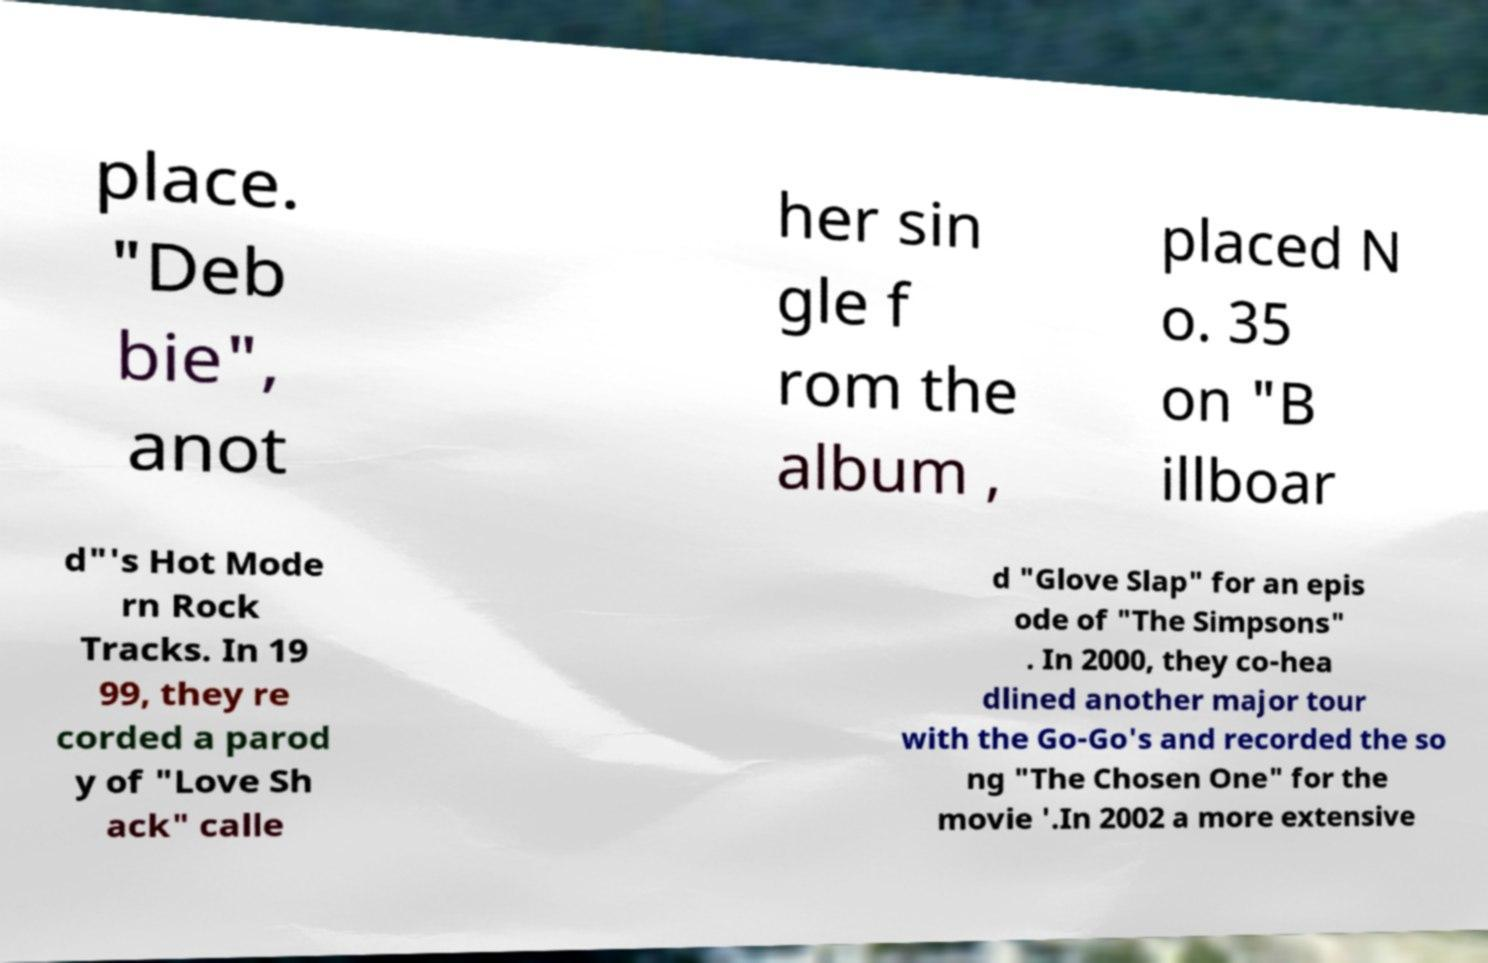Can you accurately transcribe the text from the provided image for me? place. "Deb bie", anot her sin gle f rom the album , placed N o. 35 on "B illboar d"'s Hot Mode rn Rock Tracks. In 19 99, they re corded a parod y of "Love Sh ack" calle d "Glove Slap" for an epis ode of "The Simpsons" . In 2000, they co-hea dlined another major tour with the Go-Go's and recorded the so ng "The Chosen One" for the movie '.In 2002 a more extensive 